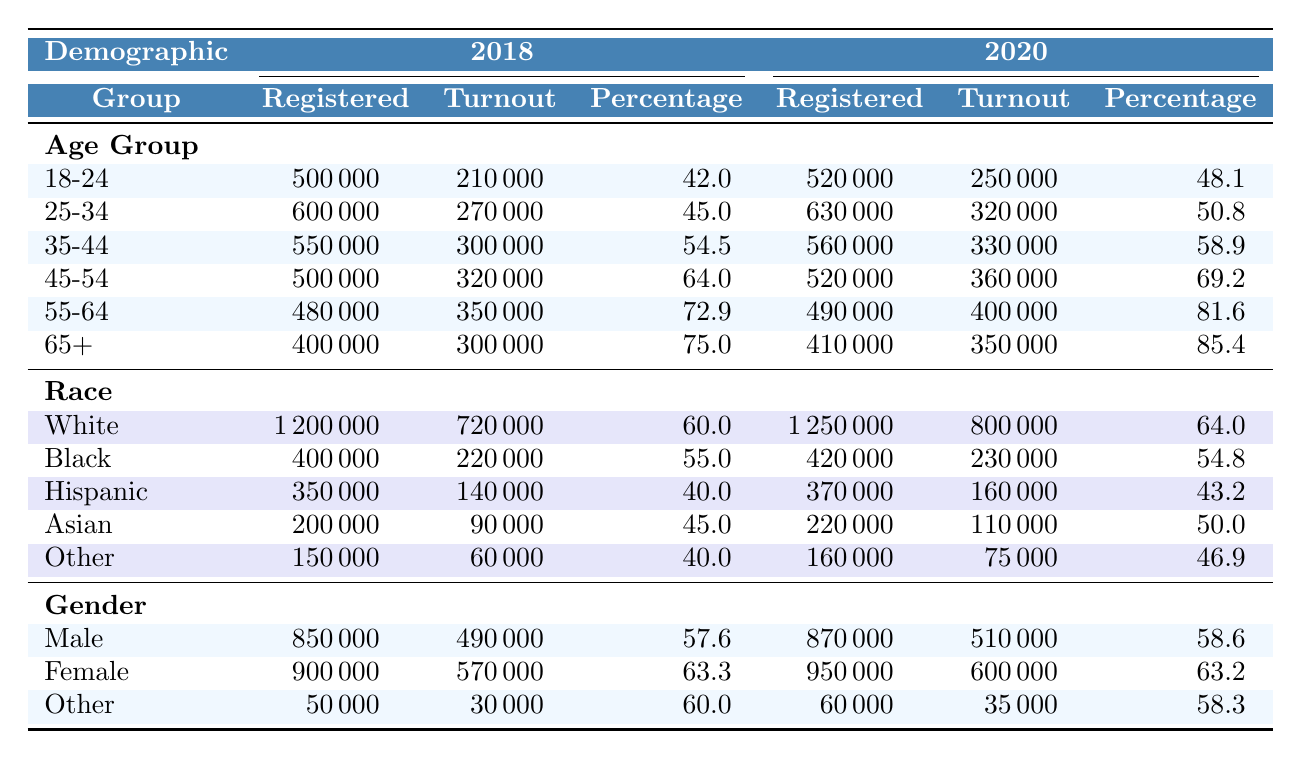What was the voter turnout percentage for the 25-34 age group in 2020? In the 2020 section of the table, the turnout percentage for the 25-34 age group is listed directly, which is 50.8%.
Answer: 50.8% Which racial group had the highest voter turnout in 2018? By examining the turnout percentages for each racial group in 2018, White had the highest voter turnout at 60%.
Answer: White What is the difference in total registered voters between the 18-24 age group for 2018 and 2020? The total registered voters for the 18-24 age group in 2018 is 500,000, and for 2020 it is 520,000. The difference is 520,000 - 500,000 = 20,000.
Answer: 20,000 How many more females voted than males in the 2020 elections? The turnout for females in 2020 is 600,000, while for males it is 510,000. The difference in turnout is 600,000 - 510,000 = 90,000.
Answer: 90,000 What was the overall trend in voter turnout for the 55-64 age group from 2018 to 2020? The voter turnout percentage for the 55-64 age group increased from 72.9% in 2018 to 81.6% in 2020, indicating an upward trend in turnout for this group.
Answer: Upward trend Which demographic group had the lowest voter turnout percentage in 2018? Looking at the turnout percentages in 2018, the Hispanic group had the lowest turnout percentage of 40%.
Answer: Hispanic If we take the average voter turnout percentage for all age groups in 2020, what is the result? The turnout percentages for the age groups in 2020 are: 48.1, 50.8, 58.9, 69.2, 81.6, and 85.4. Adding them gives 394 and dividing by 6 gives an average of 65.67%.
Answer: 65.67% Was the voter turnout for the Asian demographic higher in 2020 compared to 2018? In 2018, the turnout for Asians was 45% and in 2020 it was 50%. Since 50% is greater than 45%, the turnout was indeed higher in 2020.
Answer: Yes What is the total number of registered voters for the "Other" gender category in 2018? The "Other" gender category in 2018 shows a total of 50,000 registered voters, as listed directly in the table.
Answer: 50,000 Did Black voters have a higher turnout percentage in 2020 compared to Hispanic voters in the same year? In 2020, Black voters had a turnout percentage of 54.8%, while Hispanic voters had a turnout percentage of 43.2%. Since 54.8% is greater than 43.2%, Black voters had a higher turnout.
Answer: Yes 